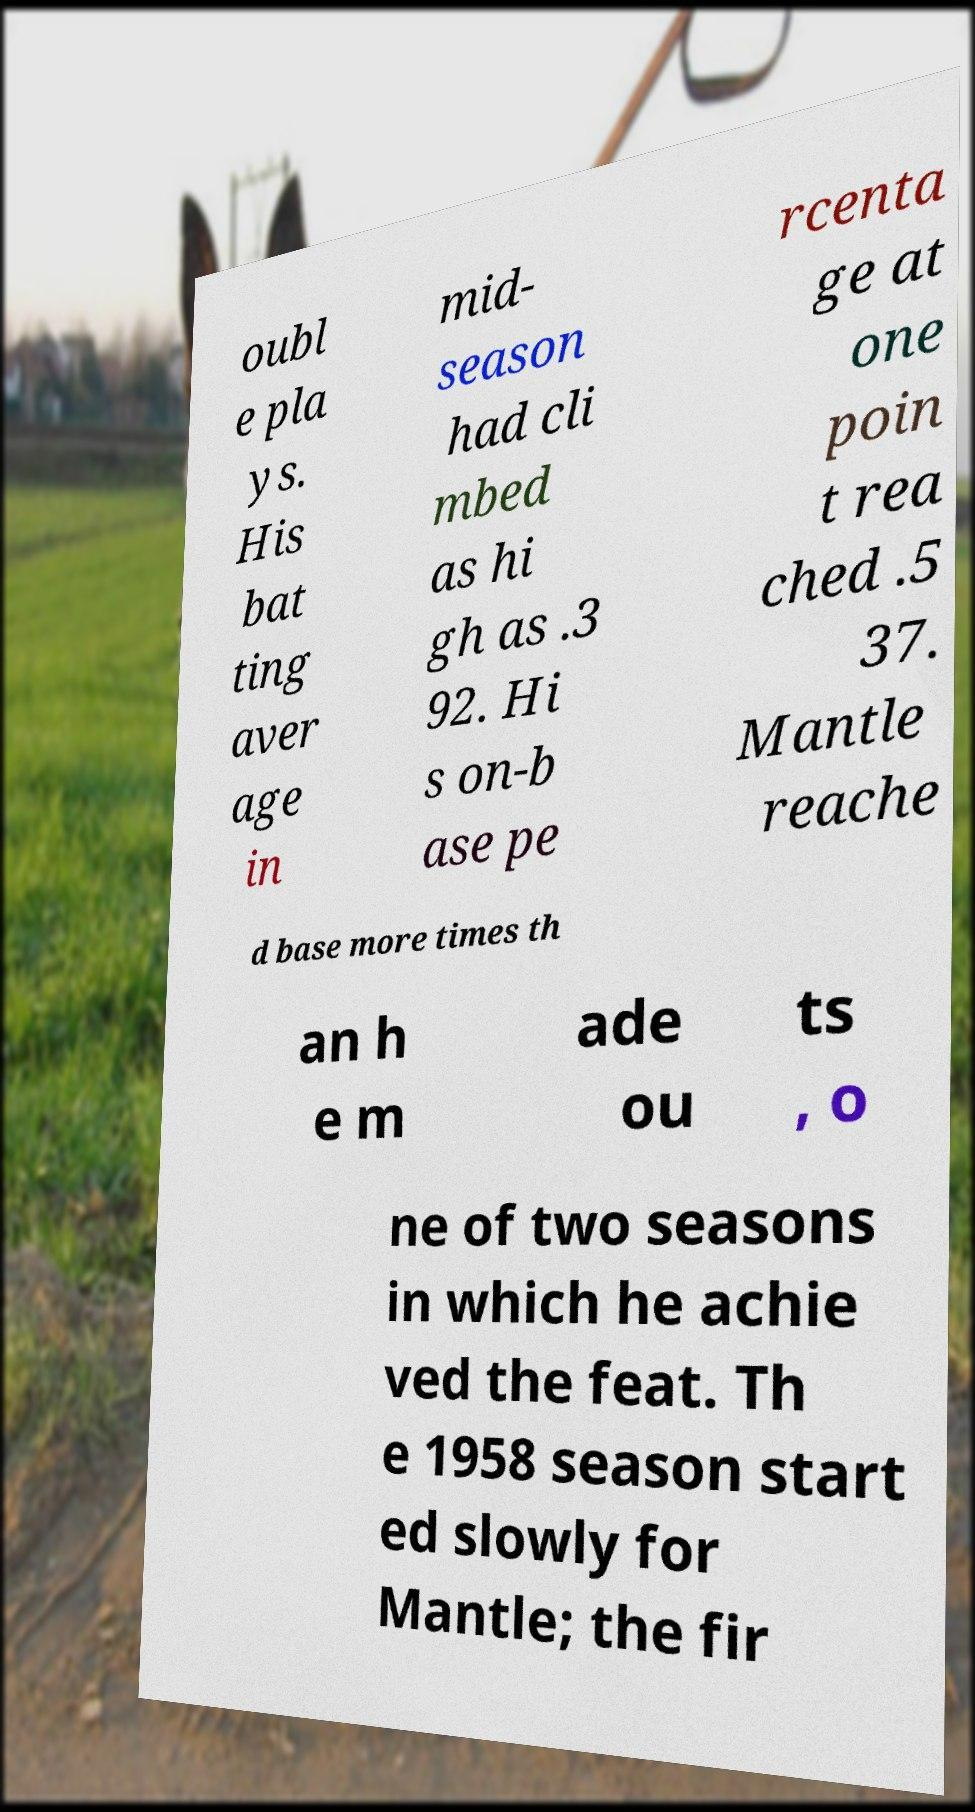Can you accurately transcribe the text from the provided image for me? oubl e pla ys. His bat ting aver age in mid- season had cli mbed as hi gh as .3 92. Hi s on-b ase pe rcenta ge at one poin t rea ched .5 37. Mantle reache d base more times th an h e m ade ou ts , o ne of two seasons in which he achie ved the feat. Th e 1958 season start ed slowly for Mantle; the fir 